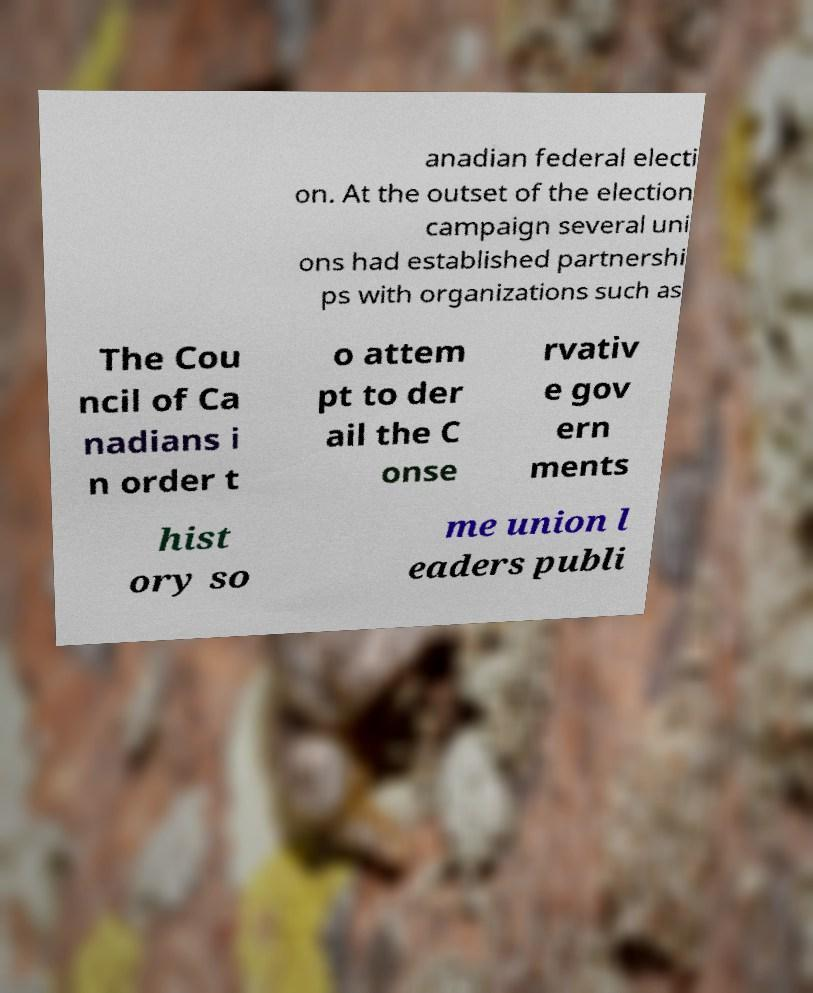For documentation purposes, I need the text within this image transcribed. Could you provide that? anadian federal electi on. At the outset of the election campaign several uni ons had established partnershi ps with organizations such as The Cou ncil of Ca nadians i n order t o attem pt to der ail the C onse rvativ e gov ern ments hist ory so me union l eaders publi 